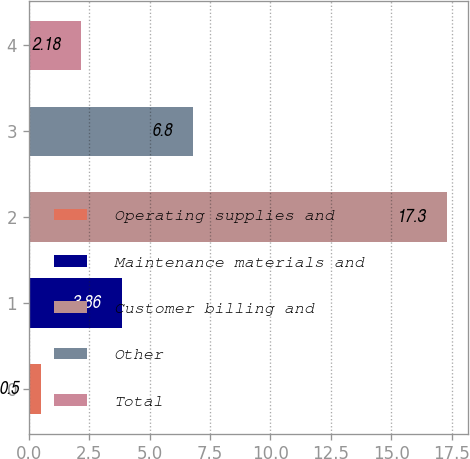<chart> <loc_0><loc_0><loc_500><loc_500><bar_chart><fcel>Operating supplies and<fcel>Maintenance materials and<fcel>Customer billing and<fcel>Other<fcel>Total<nl><fcel>0.5<fcel>3.86<fcel>17.3<fcel>6.8<fcel>2.18<nl></chart> 